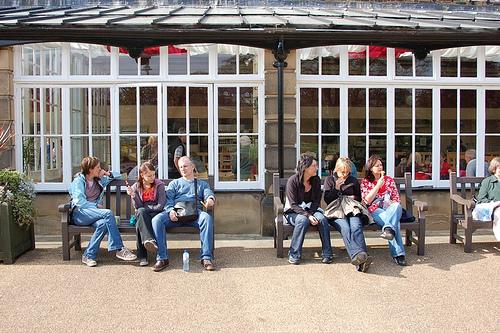Are there any windows in this picture?
Quick response, please. Yes. How many benches are visible?
Be succinct. 3. How many of the people have their legs/feet crossed?
Write a very short answer. 4. 